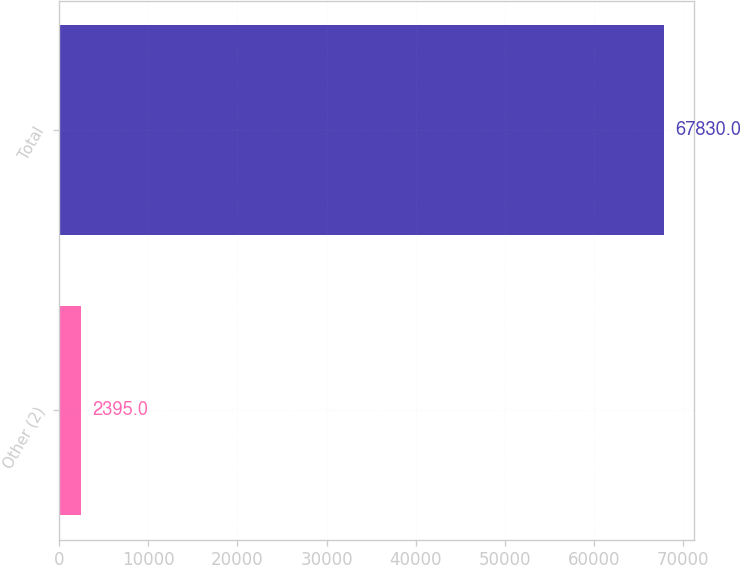<chart> <loc_0><loc_0><loc_500><loc_500><bar_chart><fcel>Other (2)<fcel>Total<nl><fcel>2395<fcel>67830<nl></chart> 